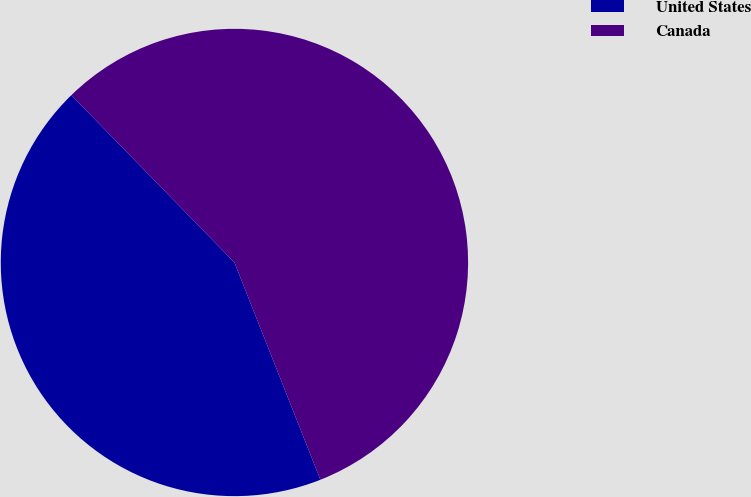<chart> <loc_0><loc_0><loc_500><loc_500><pie_chart><fcel>United States<fcel>Canada<nl><fcel>43.7%<fcel>56.3%<nl></chart> 